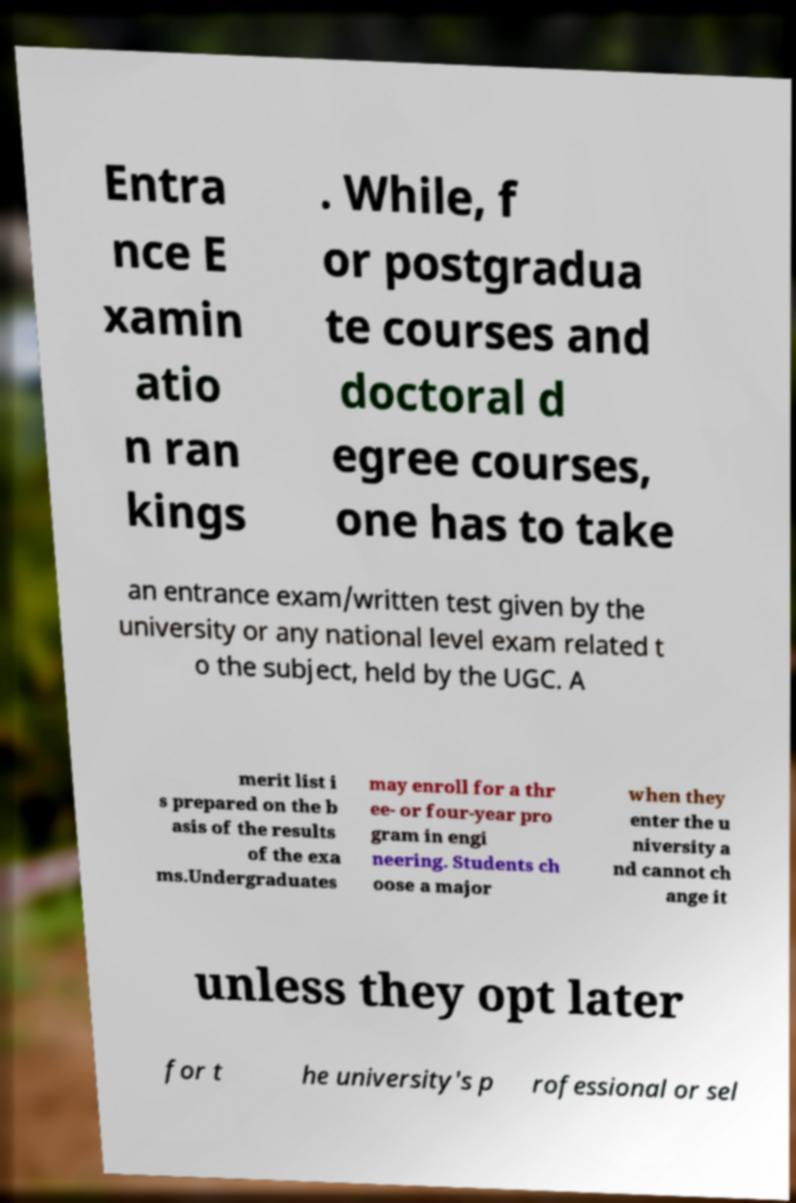What messages or text are displayed in this image? I need them in a readable, typed format. Entra nce E xamin atio n ran kings . While, f or postgradua te courses and doctoral d egree courses, one has to take an entrance exam/written test given by the university or any national level exam related t o the subject, held by the UGC. A merit list i s prepared on the b asis of the results of the exa ms.Undergraduates may enroll for a thr ee- or four-year pro gram in engi neering. Students ch oose a major when they enter the u niversity a nd cannot ch ange it unless they opt later for t he university's p rofessional or sel 